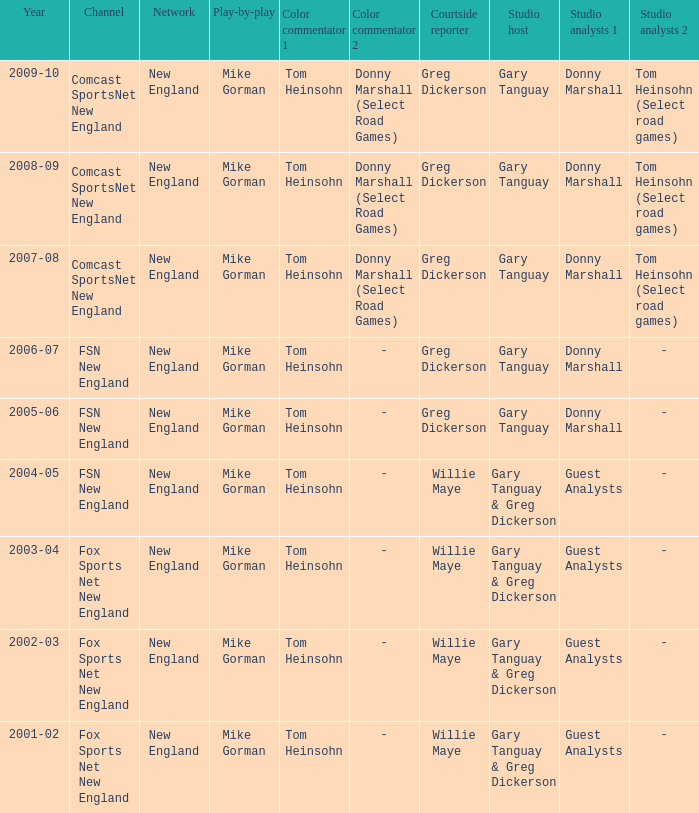How many channels were the games shown on in 2001-02? 1.0. 